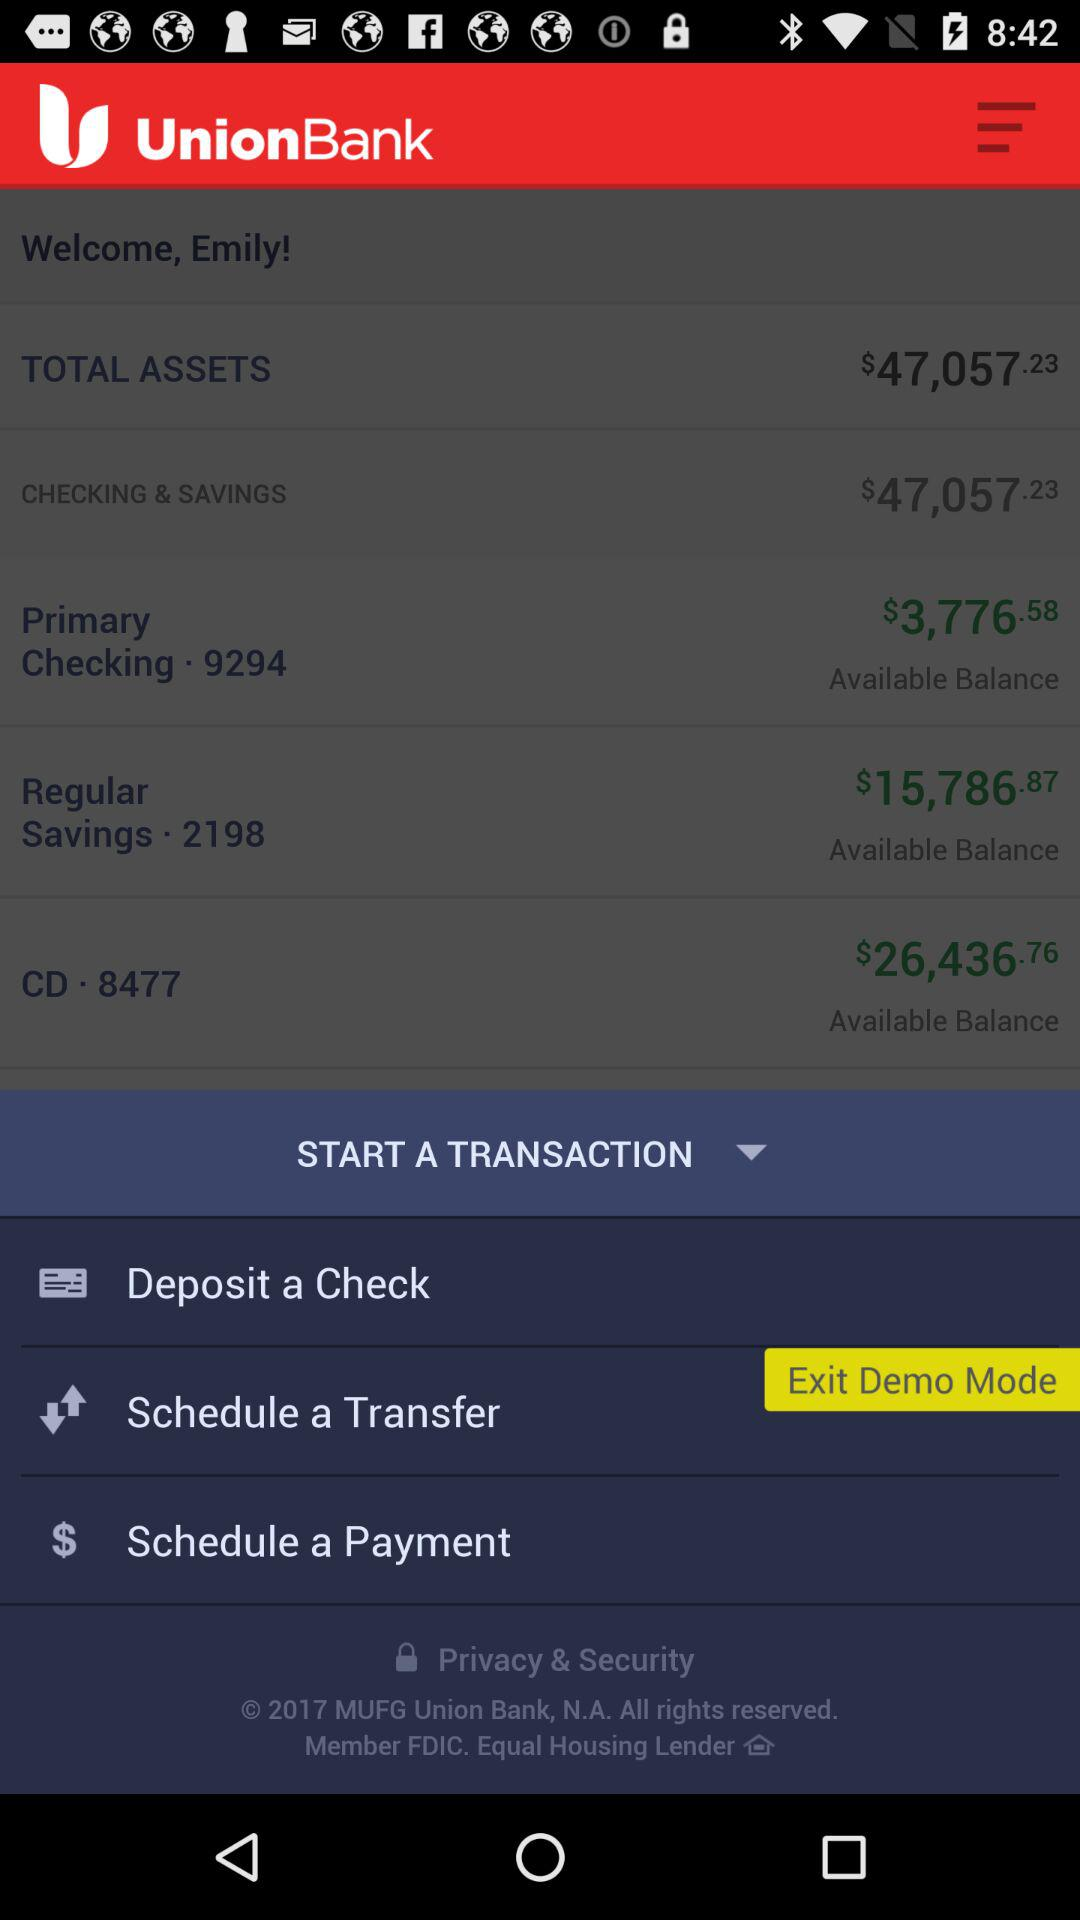What is the name of the application? The name of the application is "Union Bank Mobile Banking". 